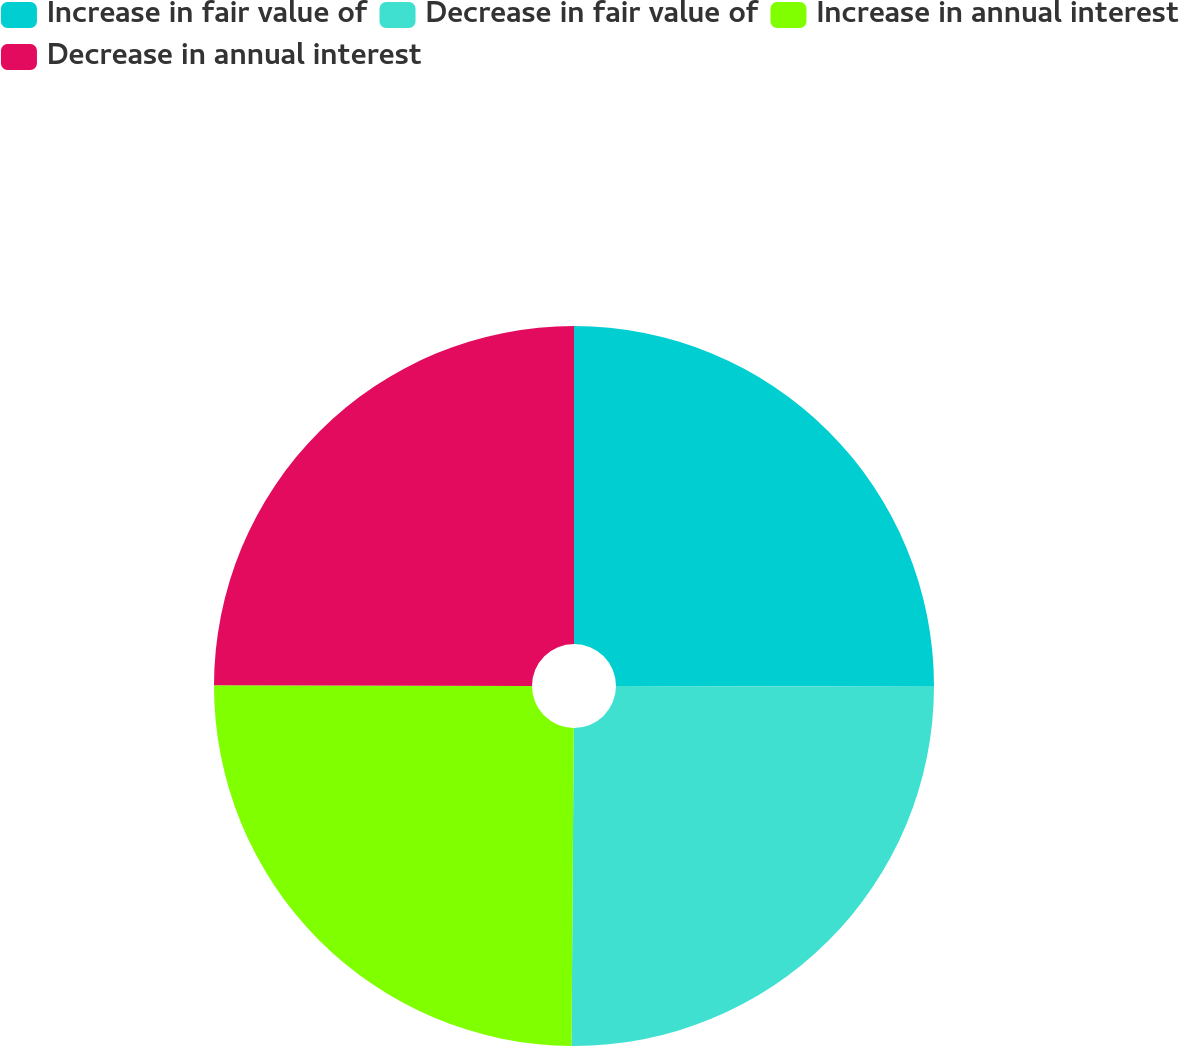<chart> <loc_0><loc_0><loc_500><loc_500><pie_chart><fcel>Increase in fair value of<fcel>Decrease in fair value of<fcel>Increase in annual interest<fcel>Decrease in annual interest<nl><fcel>25.03%<fcel>25.08%<fcel>24.92%<fcel>24.97%<nl></chart> 